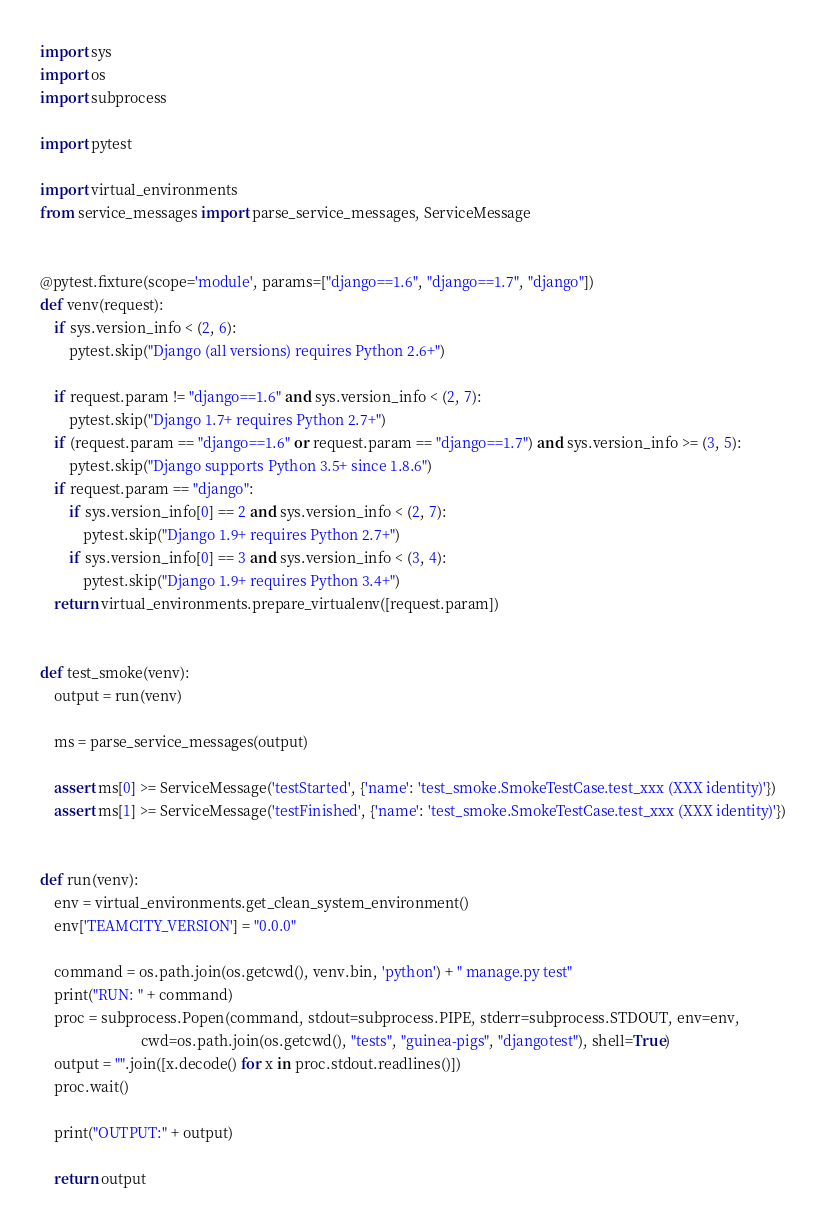Convert code to text. <code><loc_0><loc_0><loc_500><loc_500><_Python_>import sys
import os
import subprocess

import pytest

import virtual_environments
from service_messages import parse_service_messages, ServiceMessage


@pytest.fixture(scope='module', params=["django==1.6", "django==1.7", "django"])
def venv(request):
    if sys.version_info < (2, 6):
        pytest.skip("Django (all versions) requires Python 2.6+")

    if request.param != "django==1.6" and sys.version_info < (2, 7):
        pytest.skip("Django 1.7+ requires Python 2.7+")
    if (request.param == "django==1.6" or request.param == "django==1.7") and sys.version_info >= (3, 5):
        pytest.skip("Django supports Python 3.5+ since 1.8.6")
    if request.param == "django":
        if sys.version_info[0] == 2 and sys.version_info < (2, 7):
            pytest.skip("Django 1.9+ requires Python 2.7+")
        if sys.version_info[0] == 3 and sys.version_info < (3, 4):
            pytest.skip("Django 1.9+ requires Python 3.4+")
    return virtual_environments.prepare_virtualenv([request.param])


def test_smoke(venv):
    output = run(venv)

    ms = parse_service_messages(output)

    assert ms[0] >= ServiceMessage('testStarted', {'name': 'test_smoke.SmokeTestCase.test_xxx (XXX identity)'})
    assert ms[1] >= ServiceMessage('testFinished', {'name': 'test_smoke.SmokeTestCase.test_xxx (XXX identity)'})


def run(venv):
    env = virtual_environments.get_clean_system_environment()
    env['TEAMCITY_VERSION'] = "0.0.0"

    command = os.path.join(os.getcwd(), venv.bin, 'python') + " manage.py test"
    print("RUN: " + command)
    proc = subprocess.Popen(command, stdout=subprocess.PIPE, stderr=subprocess.STDOUT, env=env,
                            cwd=os.path.join(os.getcwd(), "tests", "guinea-pigs", "djangotest"), shell=True)
    output = "".join([x.decode() for x in proc.stdout.readlines()])
    proc.wait()

    print("OUTPUT:" + output)

    return output
</code> 